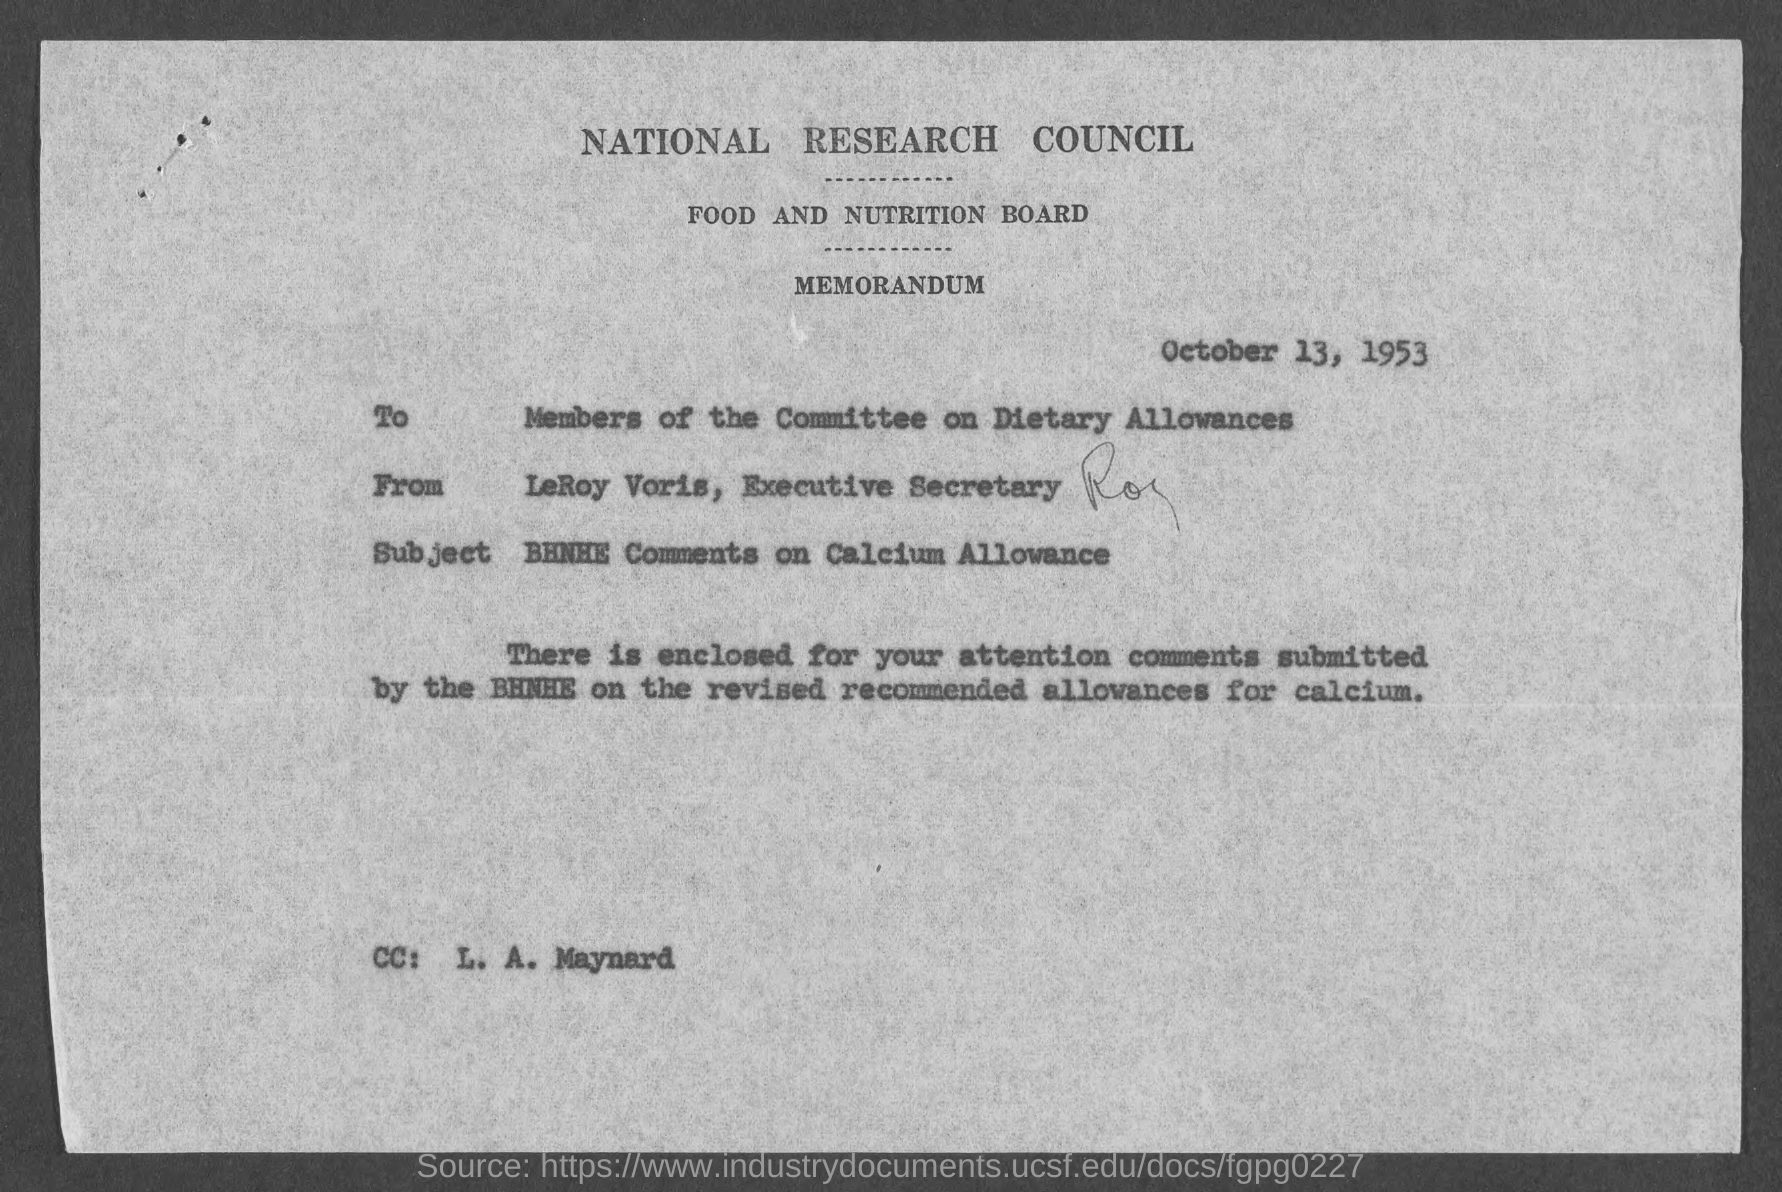Which council is mentioned?
Keep it short and to the point. NATIONAL RESEARCH COUNCIL. Which board is mentioned?
Make the answer very short. FOOD AND NUTRITION BOARD. When is the document dated?
Offer a very short reply. October 13, 1953. To whom is the memorandum addressed?
Ensure brevity in your answer.  Members of the Committee on Dietary Allowances. From whom is the memorandum?
Your answer should be compact. LeRoy Voris, Executive Secretary. What is the subject?
Ensure brevity in your answer.  BHNHE Comments on Calcium Allowance. To whom is the CC?
Make the answer very short. L. A. Maynard. 